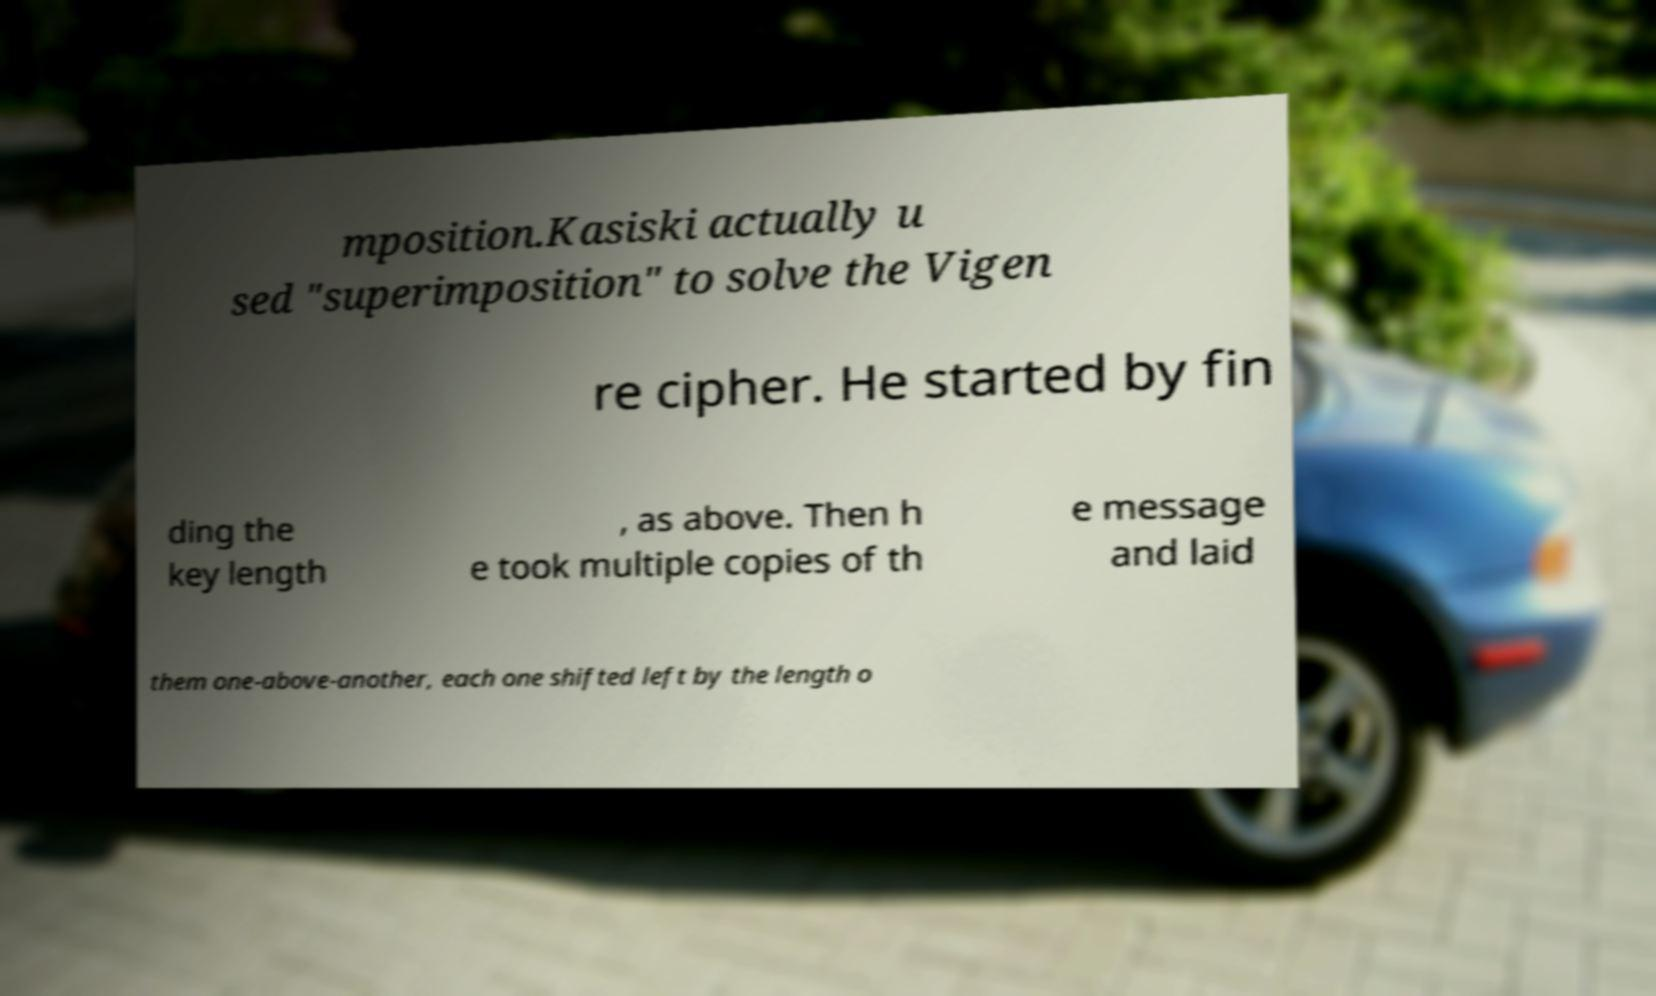Could you extract and type out the text from this image? mposition.Kasiski actually u sed "superimposition" to solve the Vigen re cipher. He started by fin ding the key length , as above. Then h e took multiple copies of th e message and laid them one-above-another, each one shifted left by the length o 